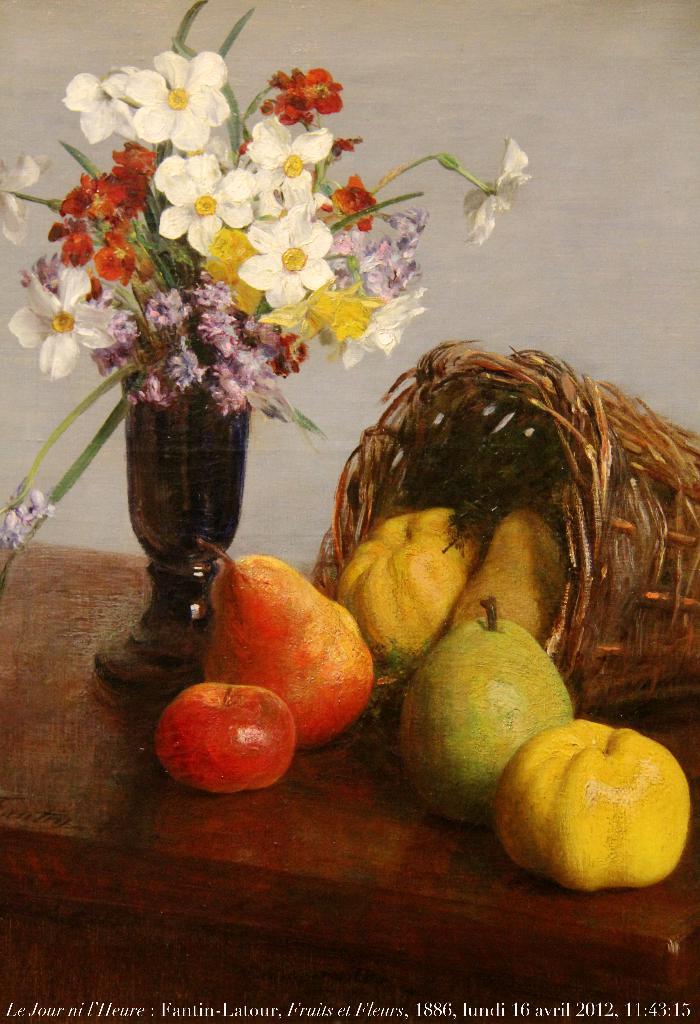How would you summarize this image in a sentence or two? In this image I can see few fruits in yellow, green and red color and the fruits are on the brown color surface and I can see few flowers in multi color. Background the wall is in white color. 